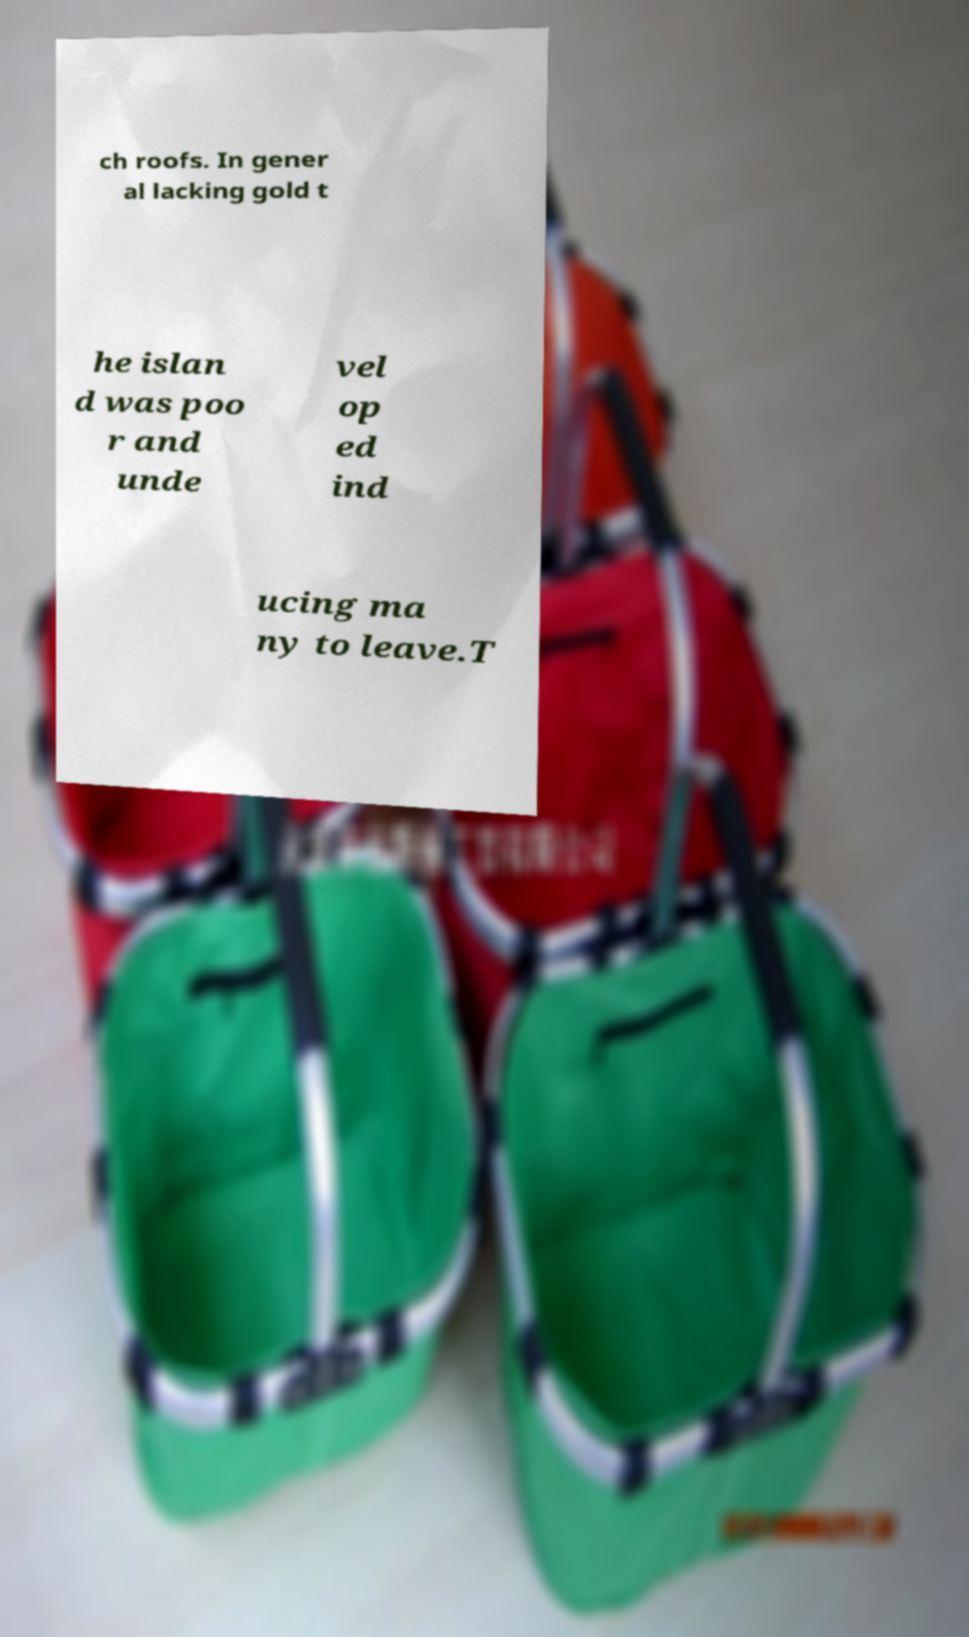Can you read and provide the text displayed in the image?This photo seems to have some interesting text. Can you extract and type it out for me? ch roofs. In gener al lacking gold t he islan d was poo r and unde vel op ed ind ucing ma ny to leave.T 